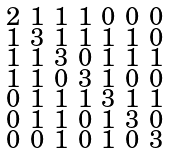<formula> <loc_0><loc_0><loc_500><loc_500>\begin{smallmatrix} 2 & 1 & 1 & 1 & 0 & 0 & 0 \\ 1 & 3 & 1 & 1 & 1 & 1 & 0 \\ 1 & 1 & 3 & 0 & 1 & 1 & 1 \\ 1 & 1 & 0 & 3 & 1 & 0 & 0 \\ 0 & 1 & 1 & 1 & 3 & 1 & 1 \\ 0 & 1 & 1 & 0 & 1 & 3 & 0 \\ 0 & 0 & 1 & 0 & 1 & 0 & 3 \end{smallmatrix}</formula> 